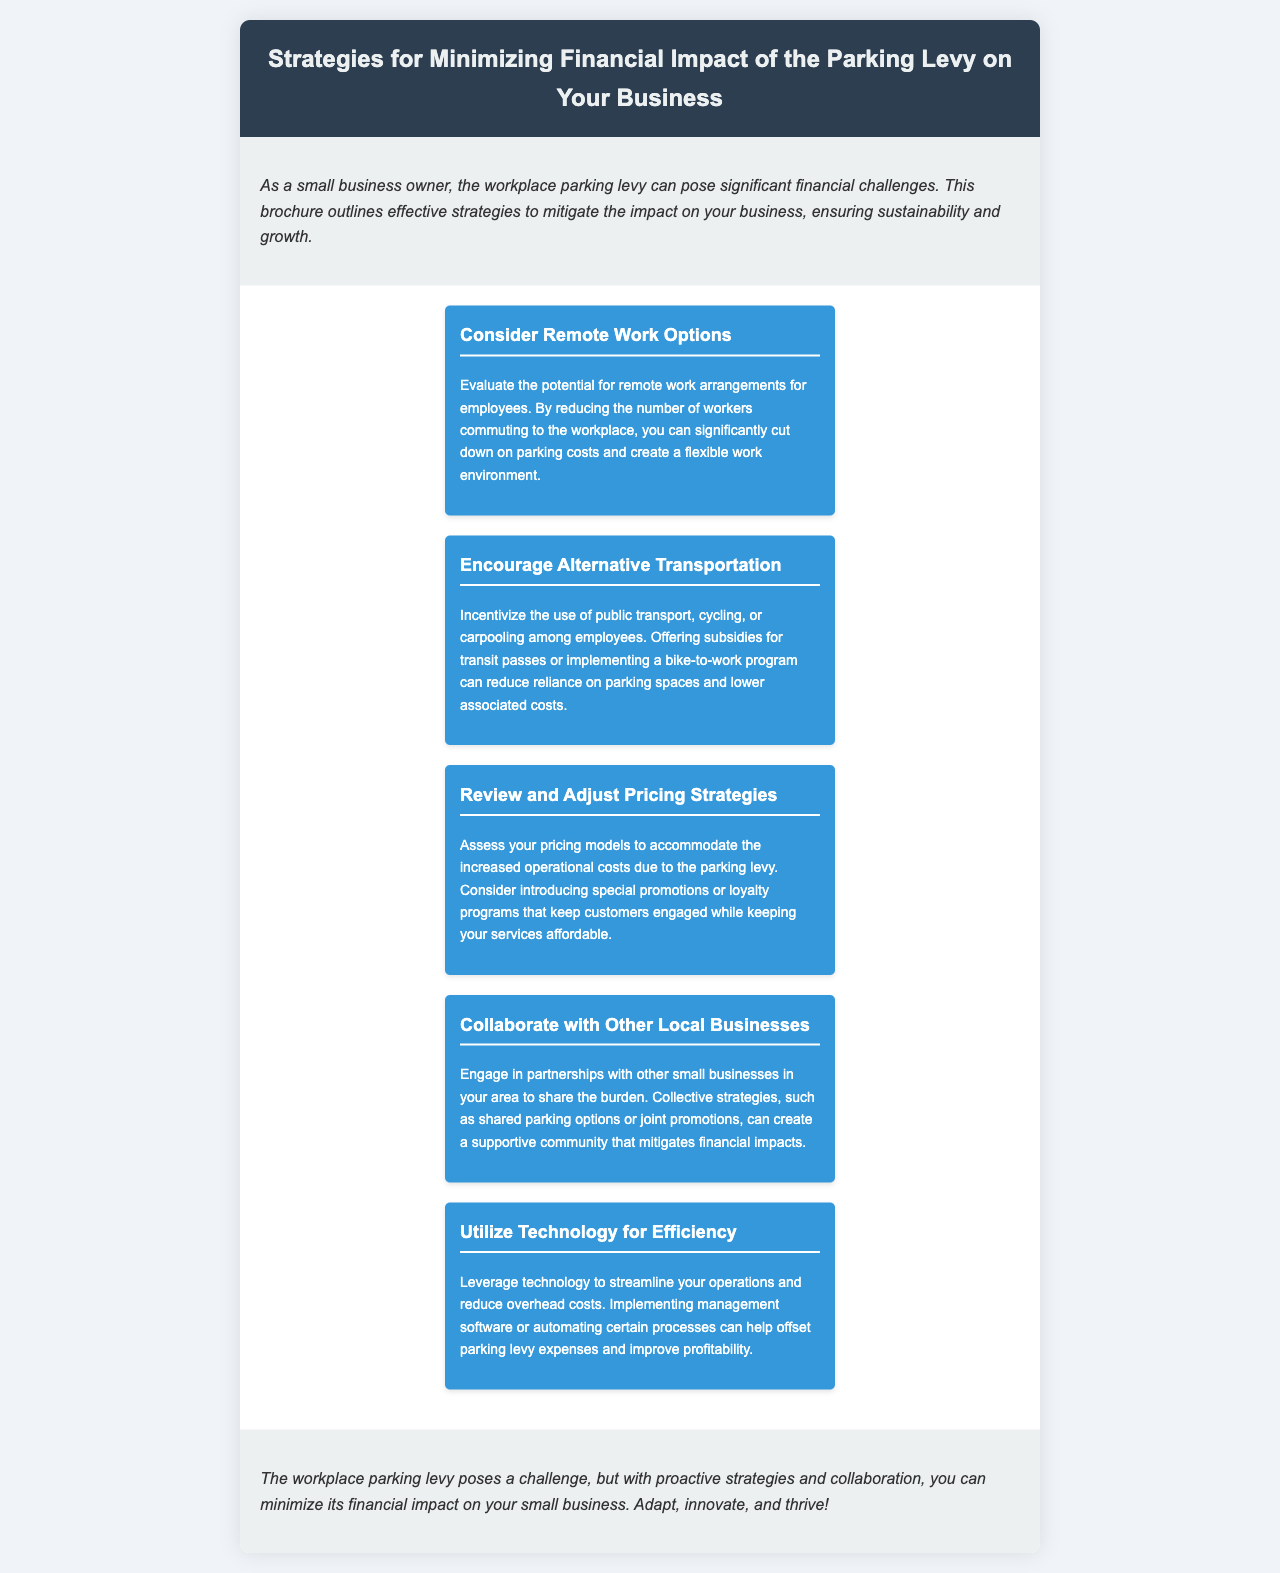What is the title of the brochure? The title of the brochure is indicated in the header section, summarizing its focus on minimizing financial impact.
Answer: Strategies for Minimizing Financial Impact of the Parking Levy on Your Business How many strategies are outlined in the document? The document enumerates distinct strategies aimed at mitigating financial burden, specifying their number in the structure.
Answer: Five Which strategy encourages the use of public transport? The brochure explicitly states this strategy in its detailed description about promoting alternative transportation methods for employees.
Answer: Encourage Alternative Transportation What is one benefit of remote work options? The advantage of this strategy is highlighted in its description, focusing on cost reduction related to commuting.
Answer: Cut down on parking costs What does the document suggest to collaborate with? This inquiry relates to the partnerships proposed within the document aimed at sharing resources and burdens among local enterprises.
Answer: Other local businesses Which color is used for the strategy boxes? The document visually represents the strategies with a specific color scheme, which can be observed in the design elements.
Answer: Blue What is the main goal of the brochure according to the conclusion? The conclusion encapsulates the document’s primary objective, summarizing how to address the identified challenges.
Answer: Minimize financial impact What technology-related suggestion is made? This question refers to the recommendation in the document that encourages utilizing specific tools to enhance operational efficiency.
Answer: Utilize Technology for Efficiency 